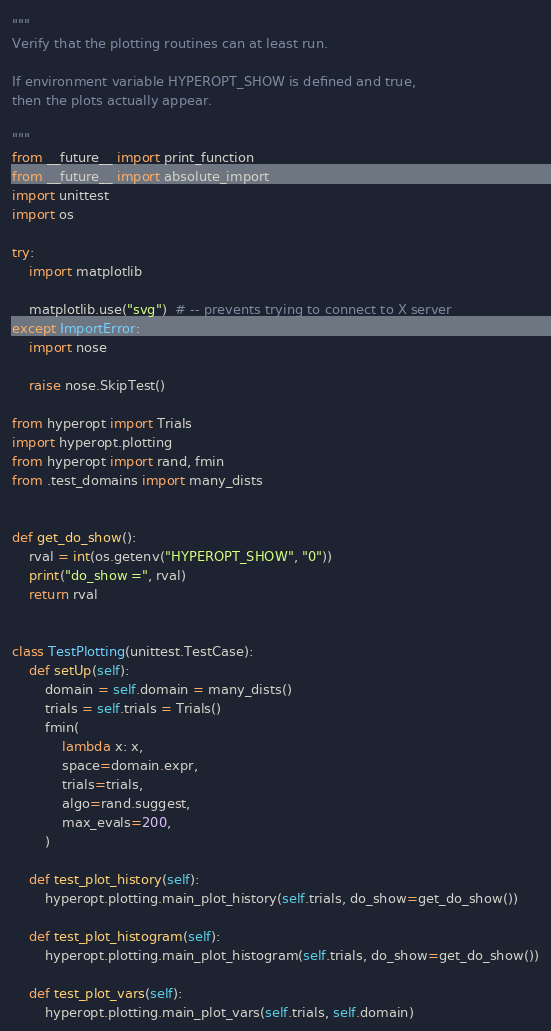Convert code to text. <code><loc_0><loc_0><loc_500><loc_500><_Python_>"""
Verify that the plotting routines can at least run.

If environment variable HYPEROPT_SHOW is defined and true,
then the plots actually appear.

"""
from __future__ import print_function
from __future__ import absolute_import
import unittest
import os

try:
    import matplotlib

    matplotlib.use("svg")  # -- prevents trying to connect to X server
except ImportError:
    import nose

    raise nose.SkipTest()

from hyperopt import Trials
import hyperopt.plotting
from hyperopt import rand, fmin
from .test_domains import many_dists


def get_do_show():
    rval = int(os.getenv("HYPEROPT_SHOW", "0"))
    print("do_show =", rval)
    return rval


class TestPlotting(unittest.TestCase):
    def setUp(self):
        domain = self.domain = many_dists()
        trials = self.trials = Trials()
        fmin(
            lambda x: x,
            space=domain.expr,
            trials=trials,
            algo=rand.suggest,
            max_evals=200,
        )

    def test_plot_history(self):
        hyperopt.plotting.main_plot_history(self.trials, do_show=get_do_show())

    def test_plot_histogram(self):
        hyperopt.plotting.main_plot_histogram(self.trials, do_show=get_do_show())

    def test_plot_vars(self):
        hyperopt.plotting.main_plot_vars(self.trials, self.domain)
</code> 